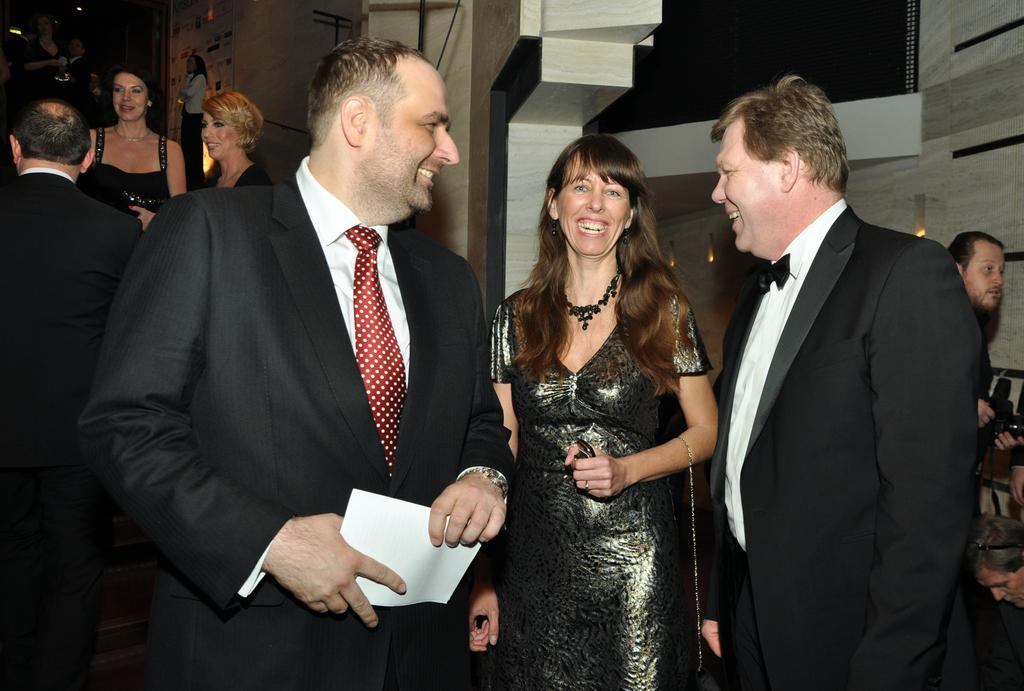How many people are in the image? There are three people in the image. What is the facial expression of the people in the image? The three people are smiling. What is one person holding in the image? One person is holding a paper. What can be seen in the background of the image? There is a group of people and a wall in the background of the image. Are there any objects visible in the background of the image? Yes, there are objects visible in the background of the image. What type of apparel is the tongue wearing in the image? There is no tongue or apparel present in the image. 